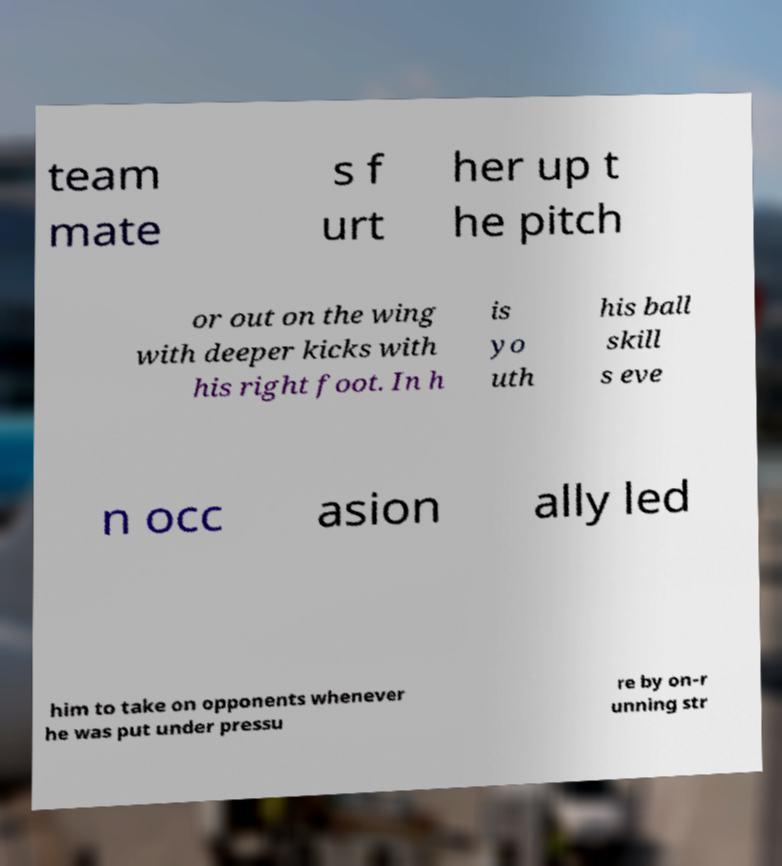Can you accurately transcribe the text from the provided image for me? team mate s f urt her up t he pitch or out on the wing with deeper kicks with his right foot. In h is yo uth his ball skill s eve n occ asion ally led him to take on opponents whenever he was put under pressu re by on-r unning str 